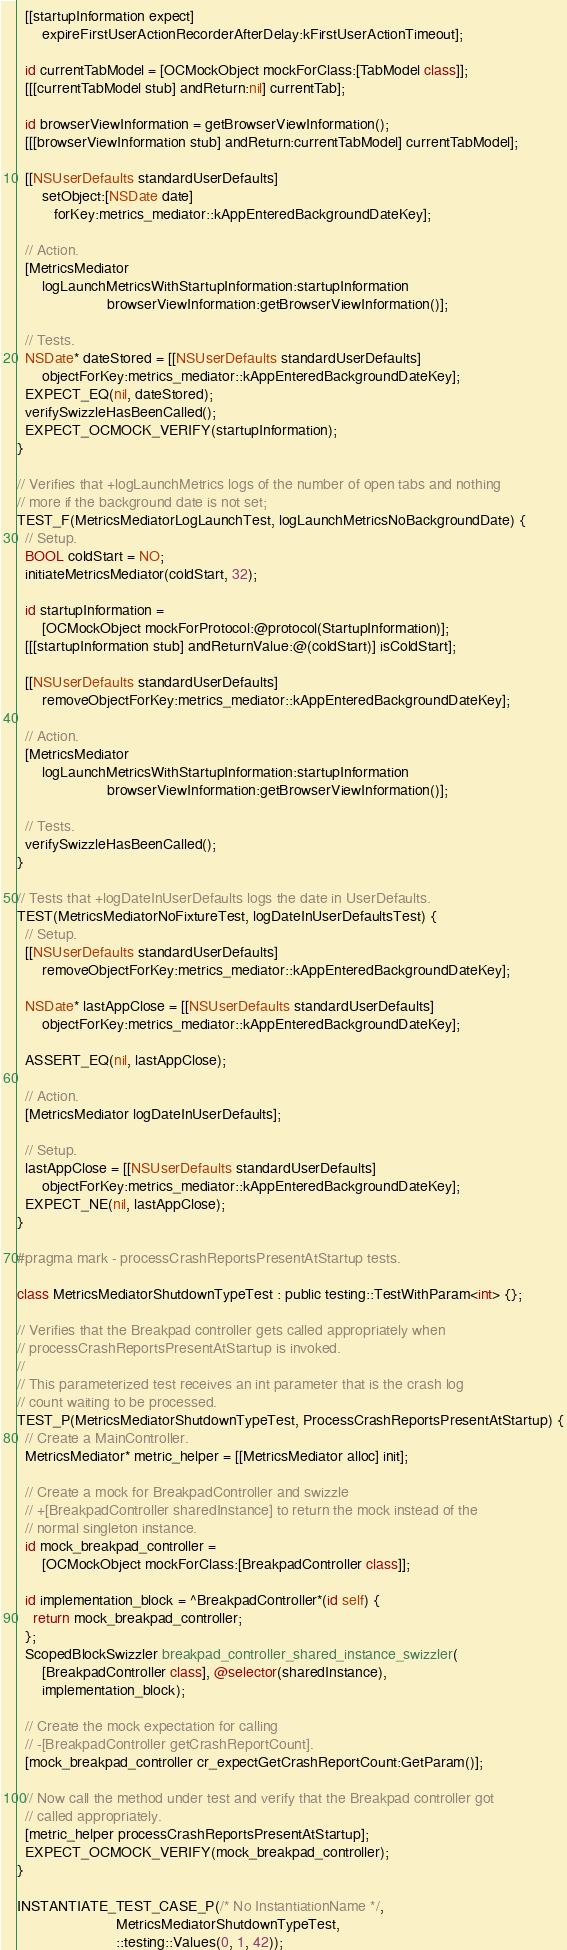<code> <loc_0><loc_0><loc_500><loc_500><_ObjectiveC_>  [[startupInformation expect]
      expireFirstUserActionRecorderAfterDelay:kFirstUserActionTimeout];

  id currentTabModel = [OCMockObject mockForClass:[TabModel class]];
  [[[currentTabModel stub] andReturn:nil] currentTab];

  id browserViewInformation = getBrowserViewInformation();
  [[[browserViewInformation stub] andReturn:currentTabModel] currentTabModel];

  [[NSUserDefaults standardUserDefaults]
      setObject:[NSDate date]
         forKey:metrics_mediator::kAppEnteredBackgroundDateKey];

  // Action.
  [MetricsMediator
      logLaunchMetricsWithStartupInformation:startupInformation
                      browserViewInformation:getBrowserViewInformation()];

  // Tests.
  NSDate* dateStored = [[NSUserDefaults standardUserDefaults]
      objectForKey:metrics_mediator::kAppEnteredBackgroundDateKey];
  EXPECT_EQ(nil, dateStored);
  verifySwizzleHasBeenCalled();
  EXPECT_OCMOCK_VERIFY(startupInformation);
}

// Verifies that +logLaunchMetrics logs of the number of open tabs and nothing
// more if the background date is not set;
TEST_F(MetricsMediatorLogLaunchTest, logLaunchMetricsNoBackgroundDate) {
  // Setup.
  BOOL coldStart = NO;
  initiateMetricsMediator(coldStart, 32);

  id startupInformation =
      [OCMockObject mockForProtocol:@protocol(StartupInformation)];
  [[[startupInformation stub] andReturnValue:@(coldStart)] isColdStart];

  [[NSUserDefaults standardUserDefaults]
      removeObjectForKey:metrics_mediator::kAppEnteredBackgroundDateKey];

  // Action.
  [MetricsMediator
      logLaunchMetricsWithStartupInformation:startupInformation
                      browserViewInformation:getBrowserViewInformation()];

  // Tests.
  verifySwizzleHasBeenCalled();
}

// Tests that +logDateInUserDefaults logs the date in UserDefaults.
TEST(MetricsMediatorNoFixtureTest, logDateInUserDefaultsTest) {
  // Setup.
  [[NSUserDefaults standardUserDefaults]
      removeObjectForKey:metrics_mediator::kAppEnteredBackgroundDateKey];

  NSDate* lastAppClose = [[NSUserDefaults standardUserDefaults]
      objectForKey:metrics_mediator::kAppEnteredBackgroundDateKey];

  ASSERT_EQ(nil, lastAppClose);

  // Action.
  [MetricsMediator logDateInUserDefaults];

  // Setup.
  lastAppClose = [[NSUserDefaults standardUserDefaults]
      objectForKey:metrics_mediator::kAppEnteredBackgroundDateKey];
  EXPECT_NE(nil, lastAppClose);
}

#pragma mark - processCrashReportsPresentAtStartup tests.

class MetricsMediatorShutdownTypeTest : public testing::TestWithParam<int> {};

// Verifies that the Breakpad controller gets called appropriately when
// processCrashReportsPresentAtStartup is invoked.
//
// This parameterized test receives an int parameter that is the crash log
// count waiting to be processed.
TEST_P(MetricsMediatorShutdownTypeTest, ProcessCrashReportsPresentAtStartup) {
  // Create a MainController.
  MetricsMediator* metric_helper = [[MetricsMediator alloc] init];

  // Create a mock for BreakpadController and swizzle
  // +[BreakpadController sharedInstance] to return the mock instead of the
  // normal singleton instance.
  id mock_breakpad_controller =
      [OCMockObject mockForClass:[BreakpadController class]];

  id implementation_block = ^BreakpadController*(id self) {
    return mock_breakpad_controller;
  };
  ScopedBlockSwizzler breakpad_controller_shared_instance_swizzler(
      [BreakpadController class], @selector(sharedInstance),
      implementation_block);

  // Create the mock expectation for calling
  // -[BreakpadController getCrashReportCount].
  [mock_breakpad_controller cr_expectGetCrashReportCount:GetParam()];

  // Now call the method under test and verify that the Breakpad controller got
  // called appropriately.
  [metric_helper processCrashReportsPresentAtStartup];
  EXPECT_OCMOCK_VERIFY(mock_breakpad_controller);
}

INSTANTIATE_TEST_CASE_P(/* No InstantiationName */,
                        MetricsMediatorShutdownTypeTest,
                        ::testing::Values(0, 1, 42));
</code> 